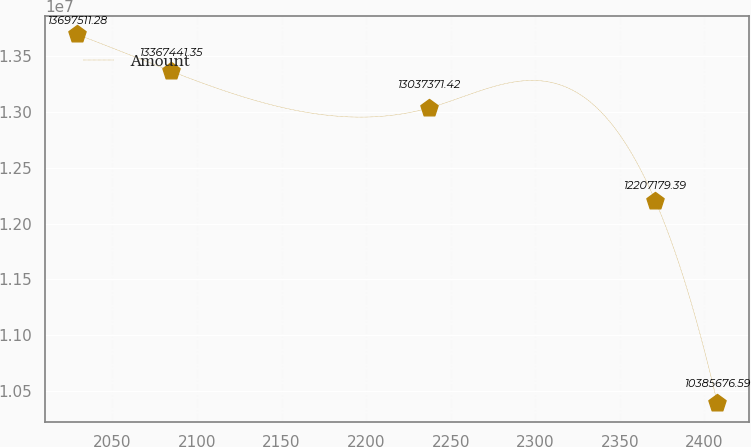Convert chart. <chart><loc_0><loc_0><loc_500><loc_500><line_chart><ecel><fcel>Amount<nl><fcel>2029.02<fcel>1.36975e+07<nl><fcel>2084.63<fcel>1.33674e+07<nl><fcel>2237.14<fcel>1.30374e+07<nl><fcel>2370.93<fcel>1.22072e+07<nl><fcel>2407.73<fcel>1.03857e+07<nl></chart> 